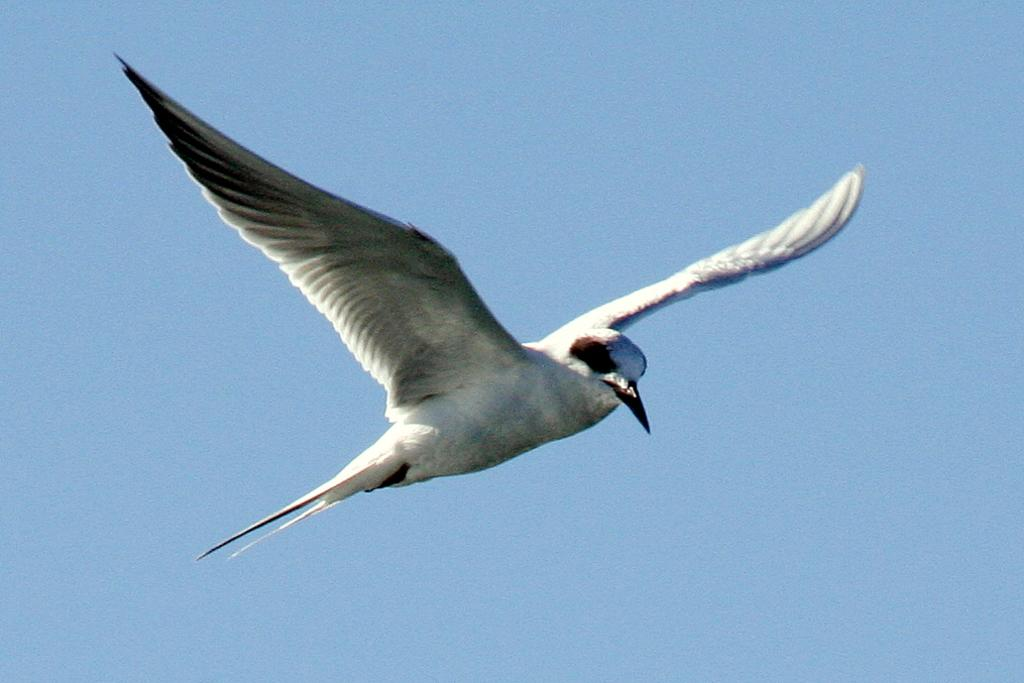What is the main subject of the image? There is a bird flying in the image. What can be seen in the background of the image? The sky is visible in the background of the image. What is the color of the sky in the image? The color of the sky is blue. What verse is the bird reciting in the image? There is no indication in the image that the bird is reciting a verse, as birds do not have the ability to speak or recite verses. 